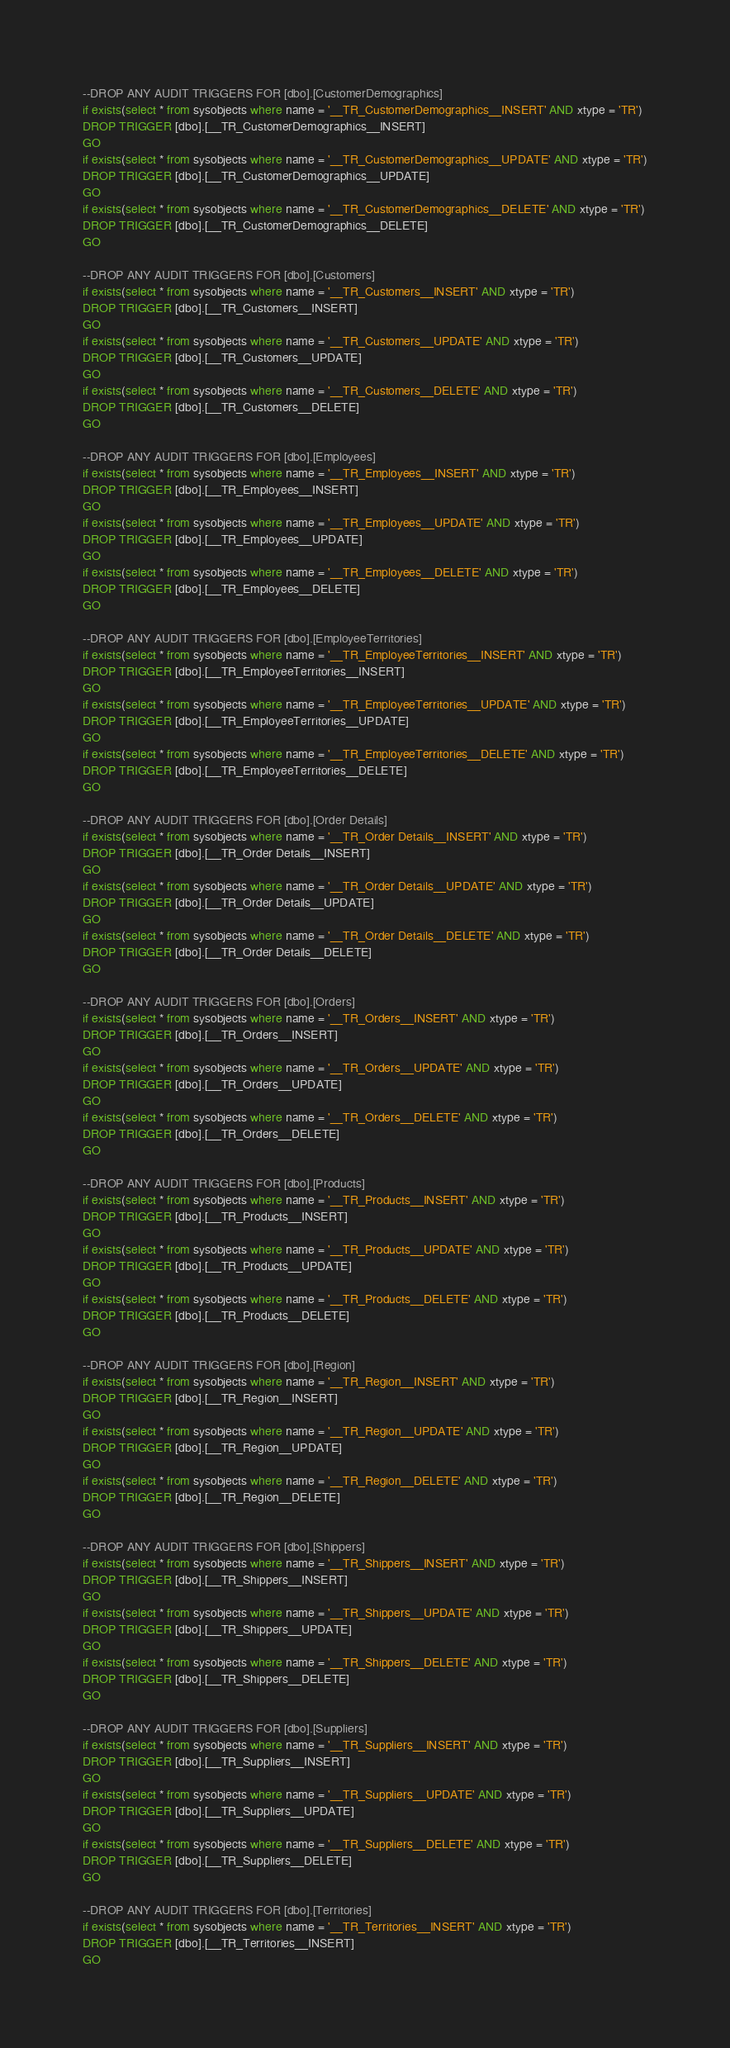<code> <loc_0><loc_0><loc_500><loc_500><_SQL_>--DROP ANY AUDIT TRIGGERS FOR [dbo].[CustomerDemographics]
if exists(select * from sysobjects where name = '__TR_CustomerDemographics__INSERT' AND xtype = 'TR')
DROP TRIGGER [dbo].[__TR_CustomerDemographics__INSERT]
GO
if exists(select * from sysobjects where name = '__TR_CustomerDemographics__UPDATE' AND xtype = 'TR')
DROP TRIGGER [dbo].[__TR_CustomerDemographics__UPDATE]
GO
if exists(select * from sysobjects where name = '__TR_CustomerDemographics__DELETE' AND xtype = 'TR')
DROP TRIGGER [dbo].[__TR_CustomerDemographics__DELETE]
GO

--DROP ANY AUDIT TRIGGERS FOR [dbo].[Customers]
if exists(select * from sysobjects where name = '__TR_Customers__INSERT' AND xtype = 'TR')
DROP TRIGGER [dbo].[__TR_Customers__INSERT]
GO
if exists(select * from sysobjects where name = '__TR_Customers__UPDATE' AND xtype = 'TR')
DROP TRIGGER [dbo].[__TR_Customers__UPDATE]
GO
if exists(select * from sysobjects where name = '__TR_Customers__DELETE' AND xtype = 'TR')
DROP TRIGGER [dbo].[__TR_Customers__DELETE]
GO

--DROP ANY AUDIT TRIGGERS FOR [dbo].[Employees]
if exists(select * from sysobjects where name = '__TR_Employees__INSERT' AND xtype = 'TR')
DROP TRIGGER [dbo].[__TR_Employees__INSERT]
GO
if exists(select * from sysobjects where name = '__TR_Employees__UPDATE' AND xtype = 'TR')
DROP TRIGGER [dbo].[__TR_Employees__UPDATE]
GO
if exists(select * from sysobjects where name = '__TR_Employees__DELETE' AND xtype = 'TR')
DROP TRIGGER [dbo].[__TR_Employees__DELETE]
GO

--DROP ANY AUDIT TRIGGERS FOR [dbo].[EmployeeTerritories]
if exists(select * from sysobjects where name = '__TR_EmployeeTerritories__INSERT' AND xtype = 'TR')
DROP TRIGGER [dbo].[__TR_EmployeeTerritories__INSERT]
GO
if exists(select * from sysobjects where name = '__TR_EmployeeTerritories__UPDATE' AND xtype = 'TR')
DROP TRIGGER [dbo].[__TR_EmployeeTerritories__UPDATE]
GO
if exists(select * from sysobjects where name = '__TR_EmployeeTerritories__DELETE' AND xtype = 'TR')
DROP TRIGGER [dbo].[__TR_EmployeeTerritories__DELETE]
GO

--DROP ANY AUDIT TRIGGERS FOR [dbo].[Order Details]
if exists(select * from sysobjects where name = '__TR_Order Details__INSERT' AND xtype = 'TR')
DROP TRIGGER [dbo].[__TR_Order Details__INSERT]
GO
if exists(select * from sysobjects where name = '__TR_Order Details__UPDATE' AND xtype = 'TR')
DROP TRIGGER [dbo].[__TR_Order Details__UPDATE]
GO
if exists(select * from sysobjects where name = '__TR_Order Details__DELETE' AND xtype = 'TR')
DROP TRIGGER [dbo].[__TR_Order Details__DELETE]
GO

--DROP ANY AUDIT TRIGGERS FOR [dbo].[Orders]
if exists(select * from sysobjects where name = '__TR_Orders__INSERT' AND xtype = 'TR')
DROP TRIGGER [dbo].[__TR_Orders__INSERT]
GO
if exists(select * from sysobjects where name = '__TR_Orders__UPDATE' AND xtype = 'TR')
DROP TRIGGER [dbo].[__TR_Orders__UPDATE]
GO
if exists(select * from sysobjects where name = '__TR_Orders__DELETE' AND xtype = 'TR')
DROP TRIGGER [dbo].[__TR_Orders__DELETE]
GO

--DROP ANY AUDIT TRIGGERS FOR [dbo].[Products]
if exists(select * from sysobjects where name = '__TR_Products__INSERT' AND xtype = 'TR')
DROP TRIGGER [dbo].[__TR_Products__INSERT]
GO
if exists(select * from sysobjects where name = '__TR_Products__UPDATE' AND xtype = 'TR')
DROP TRIGGER [dbo].[__TR_Products__UPDATE]
GO
if exists(select * from sysobjects where name = '__TR_Products__DELETE' AND xtype = 'TR')
DROP TRIGGER [dbo].[__TR_Products__DELETE]
GO

--DROP ANY AUDIT TRIGGERS FOR [dbo].[Region]
if exists(select * from sysobjects where name = '__TR_Region__INSERT' AND xtype = 'TR')
DROP TRIGGER [dbo].[__TR_Region__INSERT]
GO
if exists(select * from sysobjects where name = '__TR_Region__UPDATE' AND xtype = 'TR')
DROP TRIGGER [dbo].[__TR_Region__UPDATE]
GO
if exists(select * from sysobjects where name = '__TR_Region__DELETE' AND xtype = 'TR')
DROP TRIGGER [dbo].[__TR_Region__DELETE]
GO

--DROP ANY AUDIT TRIGGERS FOR [dbo].[Shippers]
if exists(select * from sysobjects where name = '__TR_Shippers__INSERT' AND xtype = 'TR')
DROP TRIGGER [dbo].[__TR_Shippers__INSERT]
GO
if exists(select * from sysobjects where name = '__TR_Shippers__UPDATE' AND xtype = 'TR')
DROP TRIGGER [dbo].[__TR_Shippers__UPDATE]
GO
if exists(select * from sysobjects where name = '__TR_Shippers__DELETE' AND xtype = 'TR')
DROP TRIGGER [dbo].[__TR_Shippers__DELETE]
GO

--DROP ANY AUDIT TRIGGERS FOR [dbo].[Suppliers]
if exists(select * from sysobjects where name = '__TR_Suppliers__INSERT' AND xtype = 'TR')
DROP TRIGGER [dbo].[__TR_Suppliers__INSERT]
GO
if exists(select * from sysobjects where name = '__TR_Suppliers__UPDATE' AND xtype = 'TR')
DROP TRIGGER [dbo].[__TR_Suppliers__UPDATE]
GO
if exists(select * from sysobjects where name = '__TR_Suppliers__DELETE' AND xtype = 'TR')
DROP TRIGGER [dbo].[__TR_Suppliers__DELETE]
GO

--DROP ANY AUDIT TRIGGERS FOR [dbo].[Territories]
if exists(select * from sysobjects where name = '__TR_Territories__INSERT' AND xtype = 'TR')
DROP TRIGGER [dbo].[__TR_Territories__INSERT]
GO</code> 